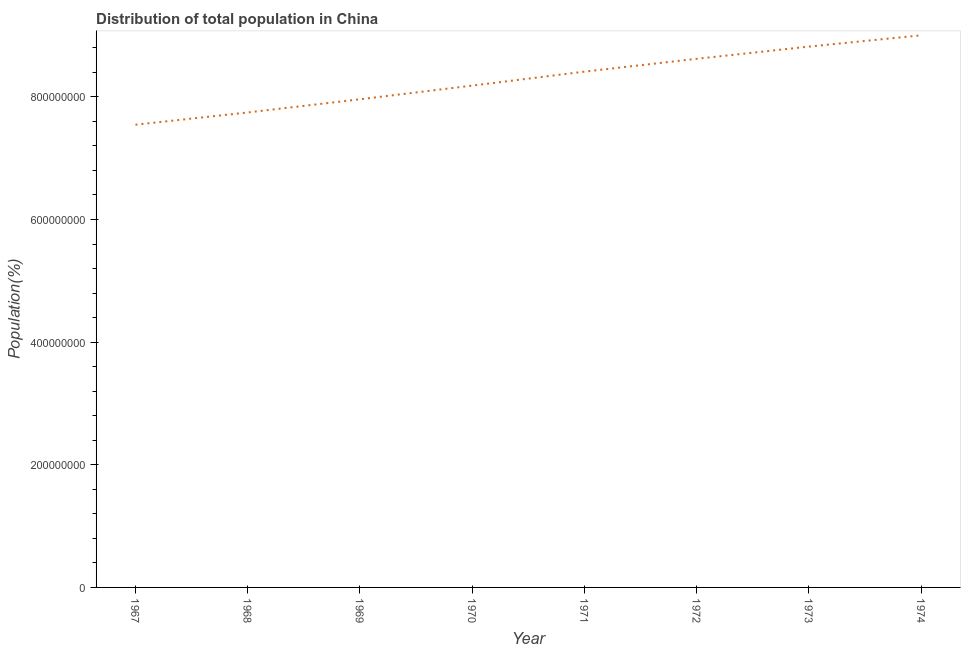What is the population in 1972?
Provide a succinct answer. 8.62e+08. Across all years, what is the maximum population?
Offer a very short reply. 9.00e+08. Across all years, what is the minimum population?
Offer a very short reply. 7.55e+08. In which year was the population maximum?
Your answer should be compact. 1974. In which year was the population minimum?
Provide a succinct answer. 1967. What is the sum of the population?
Provide a succinct answer. 6.63e+09. What is the difference between the population in 1967 and 1971?
Offer a terse response. -8.66e+07. What is the average population per year?
Offer a very short reply. 8.29e+08. What is the median population?
Your answer should be very brief. 8.30e+08. What is the ratio of the population in 1968 to that in 1973?
Ensure brevity in your answer.  0.88. What is the difference between the highest and the second highest population?
Offer a terse response. 1.84e+07. What is the difference between the highest and the lowest population?
Offer a very short reply. 1.46e+08. In how many years, is the population greater than the average population taken over all years?
Provide a short and direct response. 4. How many years are there in the graph?
Keep it short and to the point. 8. What is the difference between two consecutive major ticks on the Y-axis?
Keep it short and to the point. 2.00e+08. Does the graph contain any zero values?
Give a very brief answer. No. Does the graph contain grids?
Ensure brevity in your answer.  No. What is the title of the graph?
Your answer should be compact. Distribution of total population in China . What is the label or title of the X-axis?
Your answer should be very brief. Year. What is the label or title of the Y-axis?
Provide a succinct answer. Population(%). What is the Population(%) of 1967?
Your response must be concise. 7.55e+08. What is the Population(%) of 1968?
Offer a very short reply. 7.75e+08. What is the Population(%) in 1969?
Your answer should be compact. 7.96e+08. What is the Population(%) of 1970?
Make the answer very short. 8.18e+08. What is the Population(%) of 1971?
Keep it short and to the point. 8.41e+08. What is the Population(%) in 1972?
Your answer should be compact. 8.62e+08. What is the Population(%) of 1973?
Your answer should be very brief. 8.82e+08. What is the Population(%) in 1974?
Make the answer very short. 9.00e+08. What is the difference between the Population(%) in 1967 and 1968?
Make the answer very short. -2.00e+07. What is the difference between the Population(%) in 1967 and 1969?
Offer a terse response. -4.15e+07. What is the difference between the Population(%) in 1967 and 1970?
Your answer should be compact. -6.38e+07. What is the difference between the Population(%) in 1967 and 1971?
Provide a short and direct response. -8.66e+07. What is the difference between the Population(%) in 1967 and 1972?
Offer a very short reply. -1.07e+08. What is the difference between the Population(%) in 1967 and 1973?
Your answer should be compact. -1.27e+08. What is the difference between the Population(%) in 1967 and 1974?
Your response must be concise. -1.46e+08. What is the difference between the Population(%) in 1968 and 1969?
Your response must be concise. -2.15e+07. What is the difference between the Population(%) in 1968 and 1970?
Offer a very short reply. -4.38e+07. What is the difference between the Population(%) in 1968 and 1971?
Make the answer very short. -6.66e+07. What is the difference between the Population(%) in 1968 and 1972?
Offer a very short reply. -8.75e+07. What is the difference between the Population(%) in 1968 and 1973?
Offer a very short reply. -1.07e+08. What is the difference between the Population(%) in 1968 and 1974?
Keep it short and to the point. -1.26e+08. What is the difference between the Population(%) in 1969 and 1970?
Provide a succinct answer. -2.23e+07. What is the difference between the Population(%) in 1969 and 1971?
Make the answer very short. -4.51e+07. What is the difference between the Population(%) in 1969 and 1972?
Keep it short and to the point. -6.60e+07. What is the difference between the Population(%) in 1969 and 1973?
Keep it short and to the point. -8.59e+07. What is the difference between the Population(%) in 1969 and 1974?
Ensure brevity in your answer.  -1.04e+08. What is the difference between the Population(%) in 1970 and 1971?
Provide a short and direct response. -2.28e+07. What is the difference between the Population(%) in 1970 and 1972?
Offer a terse response. -4.37e+07. What is the difference between the Population(%) in 1970 and 1973?
Your response must be concise. -6.36e+07. What is the difference between the Population(%) in 1970 and 1974?
Offer a very short reply. -8.20e+07. What is the difference between the Population(%) in 1971 and 1972?
Offer a very short reply. -2.09e+07. What is the difference between the Population(%) in 1971 and 1973?
Provide a short and direct response. -4.08e+07. What is the difference between the Population(%) in 1971 and 1974?
Give a very brief answer. -5.92e+07. What is the difference between the Population(%) in 1972 and 1973?
Give a very brief answer. -1.99e+07. What is the difference between the Population(%) in 1972 and 1974?
Make the answer very short. -3.83e+07. What is the difference between the Population(%) in 1973 and 1974?
Offer a terse response. -1.84e+07. What is the ratio of the Population(%) in 1967 to that in 1969?
Keep it short and to the point. 0.95. What is the ratio of the Population(%) in 1967 to that in 1970?
Provide a short and direct response. 0.92. What is the ratio of the Population(%) in 1967 to that in 1971?
Your response must be concise. 0.9. What is the ratio of the Population(%) in 1967 to that in 1972?
Provide a succinct answer. 0.88. What is the ratio of the Population(%) in 1967 to that in 1973?
Your answer should be very brief. 0.86. What is the ratio of the Population(%) in 1967 to that in 1974?
Offer a very short reply. 0.84. What is the ratio of the Population(%) in 1968 to that in 1970?
Keep it short and to the point. 0.95. What is the ratio of the Population(%) in 1968 to that in 1971?
Provide a short and direct response. 0.92. What is the ratio of the Population(%) in 1968 to that in 1972?
Your answer should be compact. 0.9. What is the ratio of the Population(%) in 1968 to that in 1973?
Your answer should be compact. 0.88. What is the ratio of the Population(%) in 1968 to that in 1974?
Your response must be concise. 0.86. What is the ratio of the Population(%) in 1969 to that in 1971?
Your answer should be compact. 0.95. What is the ratio of the Population(%) in 1969 to that in 1972?
Your response must be concise. 0.92. What is the ratio of the Population(%) in 1969 to that in 1973?
Provide a succinct answer. 0.9. What is the ratio of the Population(%) in 1969 to that in 1974?
Keep it short and to the point. 0.88. What is the ratio of the Population(%) in 1970 to that in 1971?
Offer a terse response. 0.97. What is the ratio of the Population(%) in 1970 to that in 1972?
Offer a very short reply. 0.95. What is the ratio of the Population(%) in 1970 to that in 1973?
Provide a succinct answer. 0.93. What is the ratio of the Population(%) in 1970 to that in 1974?
Give a very brief answer. 0.91. What is the ratio of the Population(%) in 1971 to that in 1972?
Offer a terse response. 0.98. What is the ratio of the Population(%) in 1971 to that in 1973?
Ensure brevity in your answer.  0.95. What is the ratio of the Population(%) in 1971 to that in 1974?
Your response must be concise. 0.93. What is the ratio of the Population(%) in 1972 to that in 1973?
Ensure brevity in your answer.  0.98. 